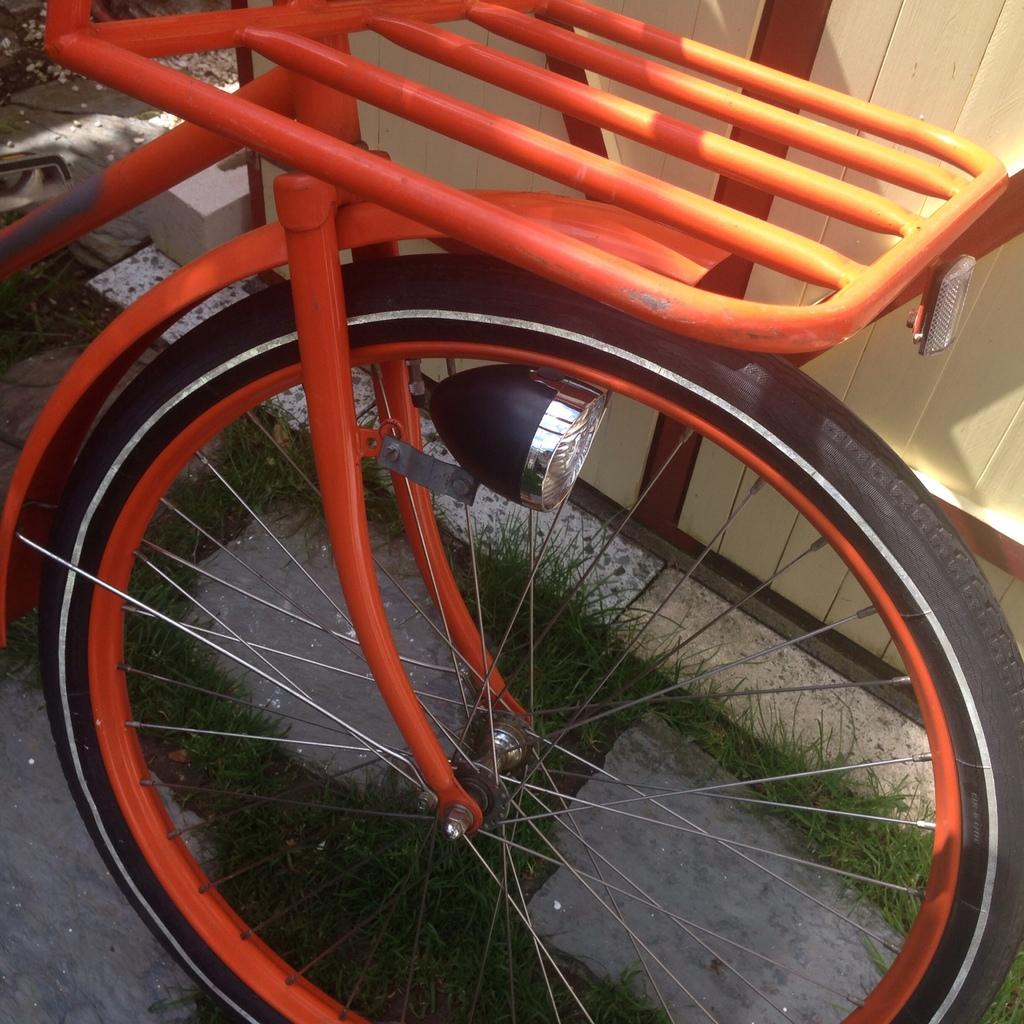What is the main subject of the image? There is a vehicle in the image. What can be seen in the background of the image? There are stones, grass, a wall, and other objects in the background of the image. Can you describe the terrain in the background? The background features stones, grass, and a wall, suggesting a mix of natural and man-made elements. What type of shop can be seen in the image? There is no shop present in the image; it features a vehicle and various elements in the background. 